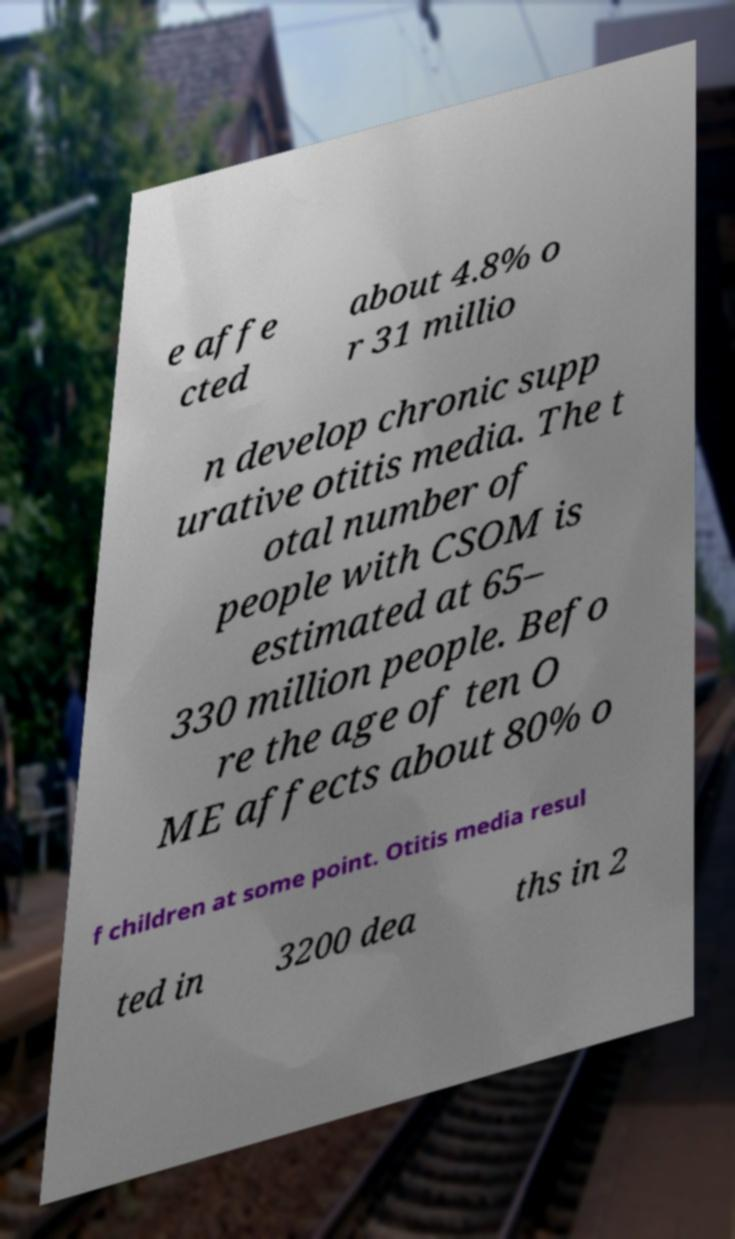Please read and relay the text visible in this image. What does it say? e affe cted about 4.8% o r 31 millio n develop chronic supp urative otitis media. The t otal number of people with CSOM is estimated at 65– 330 million people. Befo re the age of ten O ME affects about 80% o f children at some point. Otitis media resul ted in 3200 dea ths in 2 